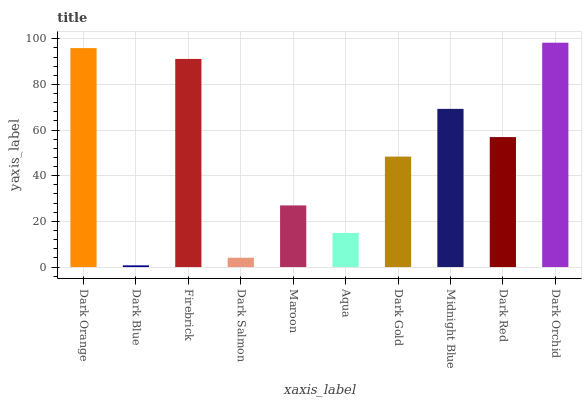Is Dark Blue the minimum?
Answer yes or no. Yes. Is Dark Orchid the maximum?
Answer yes or no. Yes. Is Firebrick the minimum?
Answer yes or no. No. Is Firebrick the maximum?
Answer yes or no. No. Is Firebrick greater than Dark Blue?
Answer yes or no. Yes. Is Dark Blue less than Firebrick?
Answer yes or no. Yes. Is Dark Blue greater than Firebrick?
Answer yes or no. No. Is Firebrick less than Dark Blue?
Answer yes or no. No. Is Dark Red the high median?
Answer yes or no. Yes. Is Dark Gold the low median?
Answer yes or no. Yes. Is Dark Salmon the high median?
Answer yes or no. No. Is Aqua the low median?
Answer yes or no. No. 